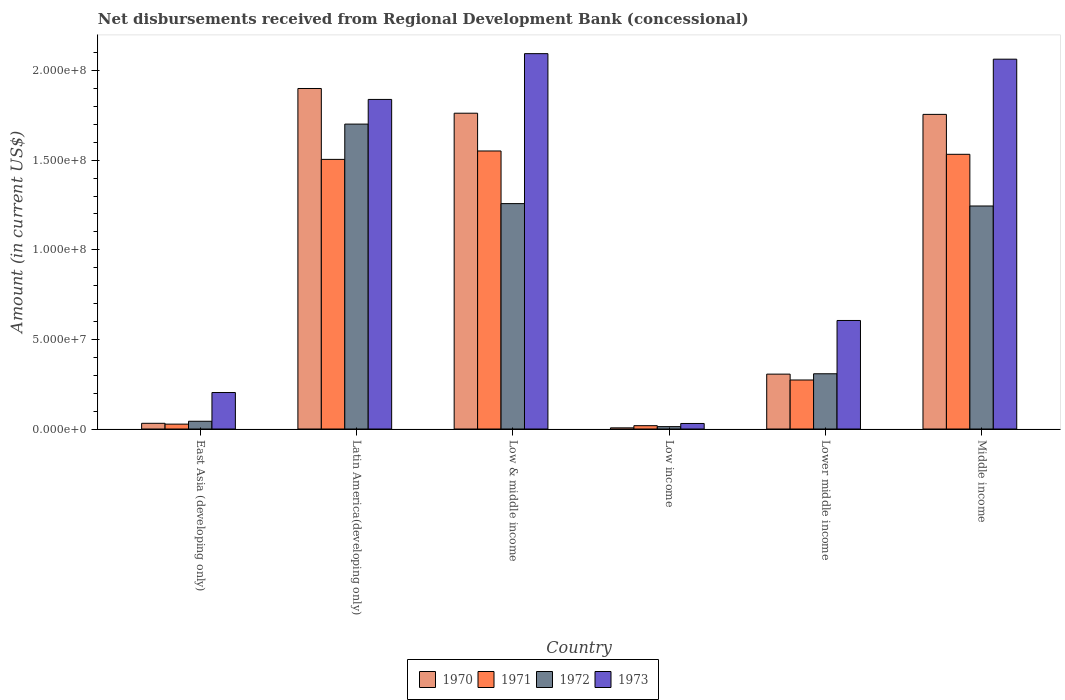How many groups of bars are there?
Your response must be concise. 6. Are the number of bars on each tick of the X-axis equal?
Ensure brevity in your answer.  Yes. How many bars are there on the 1st tick from the left?
Provide a succinct answer. 4. In how many cases, is the number of bars for a given country not equal to the number of legend labels?
Provide a succinct answer. 0. What is the amount of disbursements received from Regional Development Bank in 1973 in Low income?
Offer a terse response. 3.09e+06. Across all countries, what is the maximum amount of disbursements received from Regional Development Bank in 1971?
Ensure brevity in your answer.  1.55e+08. Across all countries, what is the minimum amount of disbursements received from Regional Development Bank in 1971?
Ensure brevity in your answer.  1.86e+06. In which country was the amount of disbursements received from Regional Development Bank in 1970 maximum?
Provide a short and direct response. Latin America(developing only). In which country was the amount of disbursements received from Regional Development Bank in 1970 minimum?
Ensure brevity in your answer.  Low income. What is the total amount of disbursements received from Regional Development Bank in 1970 in the graph?
Offer a very short reply. 5.76e+08. What is the difference between the amount of disbursements received from Regional Development Bank in 1973 in East Asia (developing only) and that in Lower middle income?
Offer a terse response. -4.02e+07. What is the difference between the amount of disbursements received from Regional Development Bank in 1973 in Middle income and the amount of disbursements received from Regional Development Bank in 1970 in Low & middle income?
Provide a short and direct response. 3.01e+07. What is the average amount of disbursements received from Regional Development Bank in 1973 per country?
Keep it short and to the point. 1.14e+08. What is the difference between the amount of disbursements received from Regional Development Bank of/in 1973 and amount of disbursements received from Regional Development Bank of/in 1972 in Middle income?
Offer a very short reply. 8.19e+07. What is the ratio of the amount of disbursements received from Regional Development Bank in 1972 in Latin America(developing only) to that in Low income?
Provide a succinct answer. 127.63. What is the difference between the highest and the second highest amount of disbursements received from Regional Development Bank in 1972?
Make the answer very short. 4.44e+07. What is the difference between the highest and the lowest amount of disbursements received from Regional Development Bank in 1973?
Your response must be concise. 2.06e+08. What does the 3rd bar from the left in Low income represents?
Your answer should be compact. 1972. Are all the bars in the graph horizontal?
Your answer should be compact. No. What is the difference between two consecutive major ticks on the Y-axis?
Your answer should be compact. 5.00e+07. Are the values on the major ticks of Y-axis written in scientific E-notation?
Your answer should be very brief. Yes. Does the graph contain grids?
Make the answer very short. No. Where does the legend appear in the graph?
Give a very brief answer. Bottom center. How many legend labels are there?
Provide a short and direct response. 4. What is the title of the graph?
Provide a succinct answer. Net disbursements received from Regional Development Bank (concessional). Does "2002" appear as one of the legend labels in the graph?
Make the answer very short. No. What is the Amount (in current US$) in 1970 in East Asia (developing only)?
Ensure brevity in your answer.  3.19e+06. What is the Amount (in current US$) of 1971 in East Asia (developing only)?
Make the answer very short. 2.73e+06. What is the Amount (in current US$) in 1972 in East Asia (developing only)?
Your response must be concise. 4.33e+06. What is the Amount (in current US$) in 1973 in East Asia (developing only)?
Offer a terse response. 2.04e+07. What is the Amount (in current US$) in 1970 in Latin America(developing only)?
Your answer should be very brief. 1.90e+08. What is the Amount (in current US$) of 1971 in Latin America(developing only)?
Your answer should be very brief. 1.50e+08. What is the Amount (in current US$) of 1972 in Latin America(developing only)?
Offer a terse response. 1.70e+08. What is the Amount (in current US$) of 1973 in Latin America(developing only)?
Provide a succinct answer. 1.84e+08. What is the Amount (in current US$) in 1970 in Low & middle income?
Make the answer very short. 1.76e+08. What is the Amount (in current US$) of 1971 in Low & middle income?
Make the answer very short. 1.55e+08. What is the Amount (in current US$) of 1972 in Low & middle income?
Keep it short and to the point. 1.26e+08. What is the Amount (in current US$) in 1973 in Low & middle income?
Provide a short and direct response. 2.09e+08. What is the Amount (in current US$) in 1970 in Low income?
Make the answer very short. 6.47e+05. What is the Amount (in current US$) of 1971 in Low income?
Provide a short and direct response. 1.86e+06. What is the Amount (in current US$) of 1972 in Low income?
Give a very brief answer. 1.33e+06. What is the Amount (in current US$) in 1973 in Low income?
Provide a short and direct response. 3.09e+06. What is the Amount (in current US$) in 1970 in Lower middle income?
Provide a succinct answer. 3.06e+07. What is the Amount (in current US$) in 1971 in Lower middle income?
Provide a short and direct response. 2.74e+07. What is the Amount (in current US$) of 1972 in Lower middle income?
Provide a short and direct response. 3.08e+07. What is the Amount (in current US$) of 1973 in Lower middle income?
Provide a short and direct response. 6.06e+07. What is the Amount (in current US$) of 1970 in Middle income?
Make the answer very short. 1.76e+08. What is the Amount (in current US$) of 1971 in Middle income?
Offer a terse response. 1.53e+08. What is the Amount (in current US$) of 1972 in Middle income?
Your response must be concise. 1.24e+08. What is the Amount (in current US$) of 1973 in Middle income?
Give a very brief answer. 2.06e+08. Across all countries, what is the maximum Amount (in current US$) of 1970?
Make the answer very short. 1.90e+08. Across all countries, what is the maximum Amount (in current US$) in 1971?
Your response must be concise. 1.55e+08. Across all countries, what is the maximum Amount (in current US$) in 1972?
Offer a very short reply. 1.70e+08. Across all countries, what is the maximum Amount (in current US$) of 1973?
Make the answer very short. 2.09e+08. Across all countries, what is the minimum Amount (in current US$) in 1970?
Ensure brevity in your answer.  6.47e+05. Across all countries, what is the minimum Amount (in current US$) in 1971?
Your response must be concise. 1.86e+06. Across all countries, what is the minimum Amount (in current US$) in 1972?
Give a very brief answer. 1.33e+06. Across all countries, what is the minimum Amount (in current US$) in 1973?
Provide a short and direct response. 3.09e+06. What is the total Amount (in current US$) of 1970 in the graph?
Make the answer very short. 5.76e+08. What is the total Amount (in current US$) in 1971 in the graph?
Your answer should be very brief. 4.91e+08. What is the total Amount (in current US$) in 1972 in the graph?
Ensure brevity in your answer.  4.57e+08. What is the total Amount (in current US$) in 1973 in the graph?
Offer a very short reply. 6.84e+08. What is the difference between the Amount (in current US$) in 1970 in East Asia (developing only) and that in Latin America(developing only)?
Offer a terse response. -1.87e+08. What is the difference between the Amount (in current US$) in 1971 in East Asia (developing only) and that in Latin America(developing only)?
Provide a succinct answer. -1.48e+08. What is the difference between the Amount (in current US$) in 1972 in East Asia (developing only) and that in Latin America(developing only)?
Keep it short and to the point. -1.66e+08. What is the difference between the Amount (in current US$) in 1973 in East Asia (developing only) and that in Latin America(developing only)?
Offer a terse response. -1.64e+08. What is the difference between the Amount (in current US$) in 1970 in East Asia (developing only) and that in Low & middle income?
Your answer should be very brief. -1.73e+08. What is the difference between the Amount (in current US$) in 1971 in East Asia (developing only) and that in Low & middle income?
Provide a short and direct response. -1.52e+08. What is the difference between the Amount (in current US$) of 1972 in East Asia (developing only) and that in Low & middle income?
Give a very brief answer. -1.21e+08. What is the difference between the Amount (in current US$) in 1973 in East Asia (developing only) and that in Low & middle income?
Give a very brief answer. -1.89e+08. What is the difference between the Amount (in current US$) in 1970 in East Asia (developing only) and that in Low income?
Ensure brevity in your answer.  2.54e+06. What is the difference between the Amount (in current US$) in 1971 in East Asia (developing only) and that in Low income?
Your answer should be very brief. 8.69e+05. What is the difference between the Amount (in current US$) of 1972 in East Asia (developing only) and that in Low income?
Your response must be concise. 2.99e+06. What is the difference between the Amount (in current US$) in 1973 in East Asia (developing only) and that in Low income?
Provide a succinct answer. 1.73e+07. What is the difference between the Amount (in current US$) of 1970 in East Asia (developing only) and that in Lower middle income?
Your response must be concise. -2.74e+07. What is the difference between the Amount (in current US$) of 1971 in East Asia (developing only) and that in Lower middle income?
Your answer should be compact. -2.46e+07. What is the difference between the Amount (in current US$) in 1972 in East Asia (developing only) and that in Lower middle income?
Your answer should be very brief. -2.65e+07. What is the difference between the Amount (in current US$) in 1973 in East Asia (developing only) and that in Lower middle income?
Make the answer very short. -4.02e+07. What is the difference between the Amount (in current US$) of 1970 in East Asia (developing only) and that in Middle income?
Make the answer very short. -1.72e+08. What is the difference between the Amount (in current US$) of 1971 in East Asia (developing only) and that in Middle income?
Provide a short and direct response. -1.51e+08. What is the difference between the Amount (in current US$) of 1972 in East Asia (developing only) and that in Middle income?
Offer a very short reply. -1.20e+08. What is the difference between the Amount (in current US$) of 1973 in East Asia (developing only) and that in Middle income?
Make the answer very short. -1.86e+08. What is the difference between the Amount (in current US$) of 1970 in Latin America(developing only) and that in Low & middle income?
Give a very brief answer. 1.38e+07. What is the difference between the Amount (in current US$) of 1971 in Latin America(developing only) and that in Low & middle income?
Your response must be concise. -4.69e+06. What is the difference between the Amount (in current US$) in 1972 in Latin America(developing only) and that in Low & middle income?
Your response must be concise. 4.44e+07. What is the difference between the Amount (in current US$) of 1973 in Latin America(developing only) and that in Low & middle income?
Keep it short and to the point. -2.55e+07. What is the difference between the Amount (in current US$) of 1970 in Latin America(developing only) and that in Low income?
Offer a very short reply. 1.89e+08. What is the difference between the Amount (in current US$) of 1971 in Latin America(developing only) and that in Low income?
Make the answer very short. 1.49e+08. What is the difference between the Amount (in current US$) in 1972 in Latin America(developing only) and that in Low income?
Give a very brief answer. 1.69e+08. What is the difference between the Amount (in current US$) in 1973 in Latin America(developing only) and that in Low income?
Ensure brevity in your answer.  1.81e+08. What is the difference between the Amount (in current US$) of 1970 in Latin America(developing only) and that in Lower middle income?
Make the answer very short. 1.59e+08. What is the difference between the Amount (in current US$) in 1971 in Latin America(developing only) and that in Lower middle income?
Provide a succinct answer. 1.23e+08. What is the difference between the Amount (in current US$) in 1972 in Latin America(developing only) and that in Lower middle income?
Your response must be concise. 1.39e+08. What is the difference between the Amount (in current US$) in 1973 in Latin America(developing only) and that in Lower middle income?
Ensure brevity in your answer.  1.23e+08. What is the difference between the Amount (in current US$) of 1970 in Latin America(developing only) and that in Middle income?
Your answer should be very brief. 1.44e+07. What is the difference between the Amount (in current US$) in 1971 in Latin America(developing only) and that in Middle income?
Provide a short and direct response. -2.84e+06. What is the difference between the Amount (in current US$) in 1972 in Latin America(developing only) and that in Middle income?
Keep it short and to the point. 4.57e+07. What is the difference between the Amount (in current US$) in 1973 in Latin America(developing only) and that in Middle income?
Provide a succinct answer. -2.25e+07. What is the difference between the Amount (in current US$) of 1970 in Low & middle income and that in Low income?
Make the answer very short. 1.76e+08. What is the difference between the Amount (in current US$) in 1971 in Low & middle income and that in Low income?
Give a very brief answer. 1.53e+08. What is the difference between the Amount (in current US$) of 1972 in Low & middle income and that in Low income?
Your answer should be very brief. 1.24e+08. What is the difference between the Amount (in current US$) in 1973 in Low & middle income and that in Low income?
Provide a succinct answer. 2.06e+08. What is the difference between the Amount (in current US$) in 1970 in Low & middle income and that in Lower middle income?
Provide a short and direct response. 1.46e+08. What is the difference between the Amount (in current US$) of 1971 in Low & middle income and that in Lower middle income?
Make the answer very short. 1.28e+08. What is the difference between the Amount (in current US$) of 1972 in Low & middle income and that in Lower middle income?
Keep it short and to the point. 9.49e+07. What is the difference between the Amount (in current US$) of 1973 in Low & middle income and that in Lower middle income?
Ensure brevity in your answer.  1.49e+08. What is the difference between the Amount (in current US$) of 1970 in Low & middle income and that in Middle income?
Offer a very short reply. 6.47e+05. What is the difference between the Amount (in current US$) in 1971 in Low & middle income and that in Middle income?
Your response must be concise. 1.86e+06. What is the difference between the Amount (in current US$) of 1972 in Low & middle income and that in Middle income?
Give a very brief answer. 1.33e+06. What is the difference between the Amount (in current US$) of 1973 in Low & middle income and that in Middle income?
Offer a terse response. 3.09e+06. What is the difference between the Amount (in current US$) of 1970 in Low income and that in Lower middle income?
Offer a terse response. -3.00e+07. What is the difference between the Amount (in current US$) in 1971 in Low income and that in Lower middle income?
Provide a succinct answer. -2.55e+07. What is the difference between the Amount (in current US$) in 1972 in Low income and that in Lower middle income?
Ensure brevity in your answer.  -2.95e+07. What is the difference between the Amount (in current US$) in 1973 in Low income and that in Lower middle income?
Provide a succinct answer. -5.75e+07. What is the difference between the Amount (in current US$) of 1970 in Low income and that in Middle income?
Provide a short and direct response. -1.75e+08. What is the difference between the Amount (in current US$) in 1971 in Low income and that in Middle income?
Your answer should be very brief. -1.51e+08. What is the difference between the Amount (in current US$) of 1972 in Low income and that in Middle income?
Provide a succinct answer. -1.23e+08. What is the difference between the Amount (in current US$) in 1973 in Low income and that in Middle income?
Offer a very short reply. -2.03e+08. What is the difference between the Amount (in current US$) in 1970 in Lower middle income and that in Middle income?
Your answer should be very brief. -1.45e+08. What is the difference between the Amount (in current US$) in 1971 in Lower middle income and that in Middle income?
Offer a very short reply. -1.26e+08. What is the difference between the Amount (in current US$) of 1972 in Lower middle income and that in Middle income?
Give a very brief answer. -9.36e+07. What is the difference between the Amount (in current US$) in 1973 in Lower middle income and that in Middle income?
Give a very brief answer. -1.46e+08. What is the difference between the Amount (in current US$) in 1970 in East Asia (developing only) and the Amount (in current US$) in 1971 in Latin America(developing only)?
Ensure brevity in your answer.  -1.47e+08. What is the difference between the Amount (in current US$) in 1970 in East Asia (developing only) and the Amount (in current US$) in 1972 in Latin America(developing only)?
Make the answer very short. -1.67e+08. What is the difference between the Amount (in current US$) in 1970 in East Asia (developing only) and the Amount (in current US$) in 1973 in Latin America(developing only)?
Offer a very short reply. -1.81e+08. What is the difference between the Amount (in current US$) of 1971 in East Asia (developing only) and the Amount (in current US$) of 1972 in Latin America(developing only)?
Your answer should be compact. -1.67e+08. What is the difference between the Amount (in current US$) of 1971 in East Asia (developing only) and the Amount (in current US$) of 1973 in Latin America(developing only)?
Offer a terse response. -1.81e+08. What is the difference between the Amount (in current US$) in 1972 in East Asia (developing only) and the Amount (in current US$) in 1973 in Latin America(developing only)?
Keep it short and to the point. -1.80e+08. What is the difference between the Amount (in current US$) in 1970 in East Asia (developing only) and the Amount (in current US$) in 1971 in Low & middle income?
Provide a succinct answer. -1.52e+08. What is the difference between the Amount (in current US$) in 1970 in East Asia (developing only) and the Amount (in current US$) in 1972 in Low & middle income?
Your answer should be very brief. -1.23e+08. What is the difference between the Amount (in current US$) in 1970 in East Asia (developing only) and the Amount (in current US$) in 1973 in Low & middle income?
Ensure brevity in your answer.  -2.06e+08. What is the difference between the Amount (in current US$) of 1971 in East Asia (developing only) and the Amount (in current US$) of 1972 in Low & middle income?
Offer a terse response. -1.23e+08. What is the difference between the Amount (in current US$) of 1971 in East Asia (developing only) and the Amount (in current US$) of 1973 in Low & middle income?
Ensure brevity in your answer.  -2.07e+08. What is the difference between the Amount (in current US$) of 1972 in East Asia (developing only) and the Amount (in current US$) of 1973 in Low & middle income?
Offer a very short reply. -2.05e+08. What is the difference between the Amount (in current US$) in 1970 in East Asia (developing only) and the Amount (in current US$) in 1971 in Low income?
Your answer should be compact. 1.33e+06. What is the difference between the Amount (in current US$) in 1970 in East Asia (developing only) and the Amount (in current US$) in 1972 in Low income?
Give a very brief answer. 1.86e+06. What is the difference between the Amount (in current US$) in 1970 in East Asia (developing only) and the Amount (in current US$) in 1973 in Low income?
Ensure brevity in your answer.  9.80e+04. What is the difference between the Amount (in current US$) in 1971 in East Asia (developing only) and the Amount (in current US$) in 1972 in Low income?
Your answer should be very brief. 1.40e+06. What is the difference between the Amount (in current US$) of 1971 in East Asia (developing only) and the Amount (in current US$) of 1973 in Low income?
Keep it short and to the point. -3.63e+05. What is the difference between the Amount (in current US$) in 1972 in East Asia (developing only) and the Amount (in current US$) in 1973 in Low income?
Your answer should be very brief. 1.24e+06. What is the difference between the Amount (in current US$) of 1970 in East Asia (developing only) and the Amount (in current US$) of 1971 in Lower middle income?
Make the answer very short. -2.42e+07. What is the difference between the Amount (in current US$) of 1970 in East Asia (developing only) and the Amount (in current US$) of 1972 in Lower middle income?
Make the answer very short. -2.76e+07. What is the difference between the Amount (in current US$) in 1970 in East Asia (developing only) and the Amount (in current US$) in 1973 in Lower middle income?
Your answer should be very brief. -5.74e+07. What is the difference between the Amount (in current US$) in 1971 in East Asia (developing only) and the Amount (in current US$) in 1972 in Lower middle income?
Ensure brevity in your answer.  -2.81e+07. What is the difference between the Amount (in current US$) of 1971 in East Asia (developing only) and the Amount (in current US$) of 1973 in Lower middle income?
Offer a terse response. -5.78e+07. What is the difference between the Amount (in current US$) of 1972 in East Asia (developing only) and the Amount (in current US$) of 1973 in Lower middle income?
Offer a very short reply. -5.62e+07. What is the difference between the Amount (in current US$) in 1970 in East Asia (developing only) and the Amount (in current US$) in 1971 in Middle income?
Make the answer very short. -1.50e+08. What is the difference between the Amount (in current US$) of 1970 in East Asia (developing only) and the Amount (in current US$) of 1972 in Middle income?
Offer a terse response. -1.21e+08. What is the difference between the Amount (in current US$) in 1970 in East Asia (developing only) and the Amount (in current US$) in 1973 in Middle income?
Make the answer very short. -2.03e+08. What is the difference between the Amount (in current US$) in 1971 in East Asia (developing only) and the Amount (in current US$) in 1972 in Middle income?
Your response must be concise. -1.22e+08. What is the difference between the Amount (in current US$) in 1971 in East Asia (developing only) and the Amount (in current US$) in 1973 in Middle income?
Ensure brevity in your answer.  -2.04e+08. What is the difference between the Amount (in current US$) in 1972 in East Asia (developing only) and the Amount (in current US$) in 1973 in Middle income?
Give a very brief answer. -2.02e+08. What is the difference between the Amount (in current US$) of 1970 in Latin America(developing only) and the Amount (in current US$) of 1971 in Low & middle income?
Offer a terse response. 3.49e+07. What is the difference between the Amount (in current US$) of 1970 in Latin America(developing only) and the Amount (in current US$) of 1972 in Low & middle income?
Give a very brief answer. 6.42e+07. What is the difference between the Amount (in current US$) of 1970 in Latin America(developing only) and the Amount (in current US$) of 1973 in Low & middle income?
Your answer should be compact. -1.94e+07. What is the difference between the Amount (in current US$) in 1971 in Latin America(developing only) and the Amount (in current US$) in 1972 in Low & middle income?
Ensure brevity in your answer.  2.47e+07. What is the difference between the Amount (in current US$) of 1971 in Latin America(developing only) and the Amount (in current US$) of 1973 in Low & middle income?
Your response must be concise. -5.90e+07. What is the difference between the Amount (in current US$) of 1972 in Latin America(developing only) and the Amount (in current US$) of 1973 in Low & middle income?
Your answer should be compact. -3.93e+07. What is the difference between the Amount (in current US$) in 1970 in Latin America(developing only) and the Amount (in current US$) in 1971 in Low income?
Give a very brief answer. 1.88e+08. What is the difference between the Amount (in current US$) in 1970 in Latin America(developing only) and the Amount (in current US$) in 1972 in Low income?
Offer a very short reply. 1.89e+08. What is the difference between the Amount (in current US$) in 1970 in Latin America(developing only) and the Amount (in current US$) in 1973 in Low income?
Give a very brief answer. 1.87e+08. What is the difference between the Amount (in current US$) in 1971 in Latin America(developing only) and the Amount (in current US$) in 1972 in Low income?
Your answer should be very brief. 1.49e+08. What is the difference between the Amount (in current US$) in 1971 in Latin America(developing only) and the Amount (in current US$) in 1973 in Low income?
Ensure brevity in your answer.  1.47e+08. What is the difference between the Amount (in current US$) of 1972 in Latin America(developing only) and the Amount (in current US$) of 1973 in Low income?
Keep it short and to the point. 1.67e+08. What is the difference between the Amount (in current US$) of 1970 in Latin America(developing only) and the Amount (in current US$) of 1971 in Lower middle income?
Ensure brevity in your answer.  1.63e+08. What is the difference between the Amount (in current US$) of 1970 in Latin America(developing only) and the Amount (in current US$) of 1972 in Lower middle income?
Your response must be concise. 1.59e+08. What is the difference between the Amount (in current US$) of 1970 in Latin America(developing only) and the Amount (in current US$) of 1973 in Lower middle income?
Give a very brief answer. 1.29e+08. What is the difference between the Amount (in current US$) in 1971 in Latin America(developing only) and the Amount (in current US$) in 1972 in Lower middle income?
Your answer should be very brief. 1.20e+08. What is the difference between the Amount (in current US$) in 1971 in Latin America(developing only) and the Amount (in current US$) in 1973 in Lower middle income?
Offer a very short reply. 8.99e+07. What is the difference between the Amount (in current US$) of 1972 in Latin America(developing only) and the Amount (in current US$) of 1973 in Lower middle income?
Keep it short and to the point. 1.10e+08. What is the difference between the Amount (in current US$) of 1970 in Latin America(developing only) and the Amount (in current US$) of 1971 in Middle income?
Your answer should be very brief. 3.67e+07. What is the difference between the Amount (in current US$) of 1970 in Latin America(developing only) and the Amount (in current US$) of 1972 in Middle income?
Keep it short and to the point. 6.56e+07. What is the difference between the Amount (in current US$) in 1970 in Latin America(developing only) and the Amount (in current US$) in 1973 in Middle income?
Your answer should be very brief. -1.64e+07. What is the difference between the Amount (in current US$) of 1971 in Latin America(developing only) and the Amount (in current US$) of 1972 in Middle income?
Keep it short and to the point. 2.60e+07. What is the difference between the Amount (in current US$) in 1971 in Latin America(developing only) and the Amount (in current US$) in 1973 in Middle income?
Provide a succinct answer. -5.59e+07. What is the difference between the Amount (in current US$) in 1972 in Latin America(developing only) and the Amount (in current US$) in 1973 in Middle income?
Offer a terse response. -3.62e+07. What is the difference between the Amount (in current US$) in 1970 in Low & middle income and the Amount (in current US$) in 1971 in Low income?
Offer a very short reply. 1.74e+08. What is the difference between the Amount (in current US$) of 1970 in Low & middle income and the Amount (in current US$) of 1972 in Low income?
Your response must be concise. 1.75e+08. What is the difference between the Amount (in current US$) of 1970 in Low & middle income and the Amount (in current US$) of 1973 in Low income?
Keep it short and to the point. 1.73e+08. What is the difference between the Amount (in current US$) of 1971 in Low & middle income and the Amount (in current US$) of 1972 in Low income?
Give a very brief answer. 1.54e+08. What is the difference between the Amount (in current US$) of 1971 in Low & middle income and the Amount (in current US$) of 1973 in Low income?
Your answer should be very brief. 1.52e+08. What is the difference between the Amount (in current US$) in 1972 in Low & middle income and the Amount (in current US$) in 1973 in Low income?
Keep it short and to the point. 1.23e+08. What is the difference between the Amount (in current US$) of 1970 in Low & middle income and the Amount (in current US$) of 1971 in Lower middle income?
Make the answer very short. 1.49e+08. What is the difference between the Amount (in current US$) of 1970 in Low & middle income and the Amount (in current US$) of 1972 in Lower middle income?
Your answer should be compact. 1.45e+08. What is the difference between the Amount (in current US$) of 1970 in Low & middle income and the Amount (in current US$) of 1973 in Lower middle income?
Your response must be concise. 1.16e+08. What is the difference between the Amount (in current US$) in 1971 in Low & middle income and the Amount (in current US$) in 1972 in Lower middle income?
Offer a terse response. 1.24e+08. What is the difference between the Amount (in current US$) of 1971 in Low & middle income and the Amount (in current US$) of 1973 in Lower middle income?
Your answer should be very brief. 9.46e+07. What is the difference between the Amount (in current US$) in 1972 in Low & middle income and the Amount (in current US$) in 1973 in Lower middle income?
Provide a short and direct response. 6.52e+07. What is the difference between the Amount (in current US$) in 1970 in Low & middle income and the Amount (in current US$) in 1971 in Middle income?
Your response must be concise. 2.29e+07. What is the difference between the Amount (in current US$) of 1970 in Low & middle income and the Amount (in current US$) of 1972 in Middle income?
Provide a short and direct response. 5.18e+07. What is the difference between the Amount (in current US$) of 1970 in Low & middle income and the Amount (in current US$) of 1973 in Middle income?
Give a very brief answer. -3.01e+07. What is the difference between the Amount (in current US$) in 1971 in Low & middle income and the Amount (in current US$) in 1972 in Middle income?
Your answer should be very brief. 3.07e+07. What is the difference between the Amount (in current US$) of 1971 in Low & middle income and the Amount (in current US$) of 1973 in Middle income?
Ensure brevity in your answer.  -5.12e+07. What is the difference between the Amount (in current US$) in 1972 in Low & middle income and the Amount (in current US$) in 1973 in Middle income?
Provide a succinct answer. -8.06e+07. What is the difference between the Amount (in current US$) in 1970 in Low income and the Amount (in current US$) in 1971 in Lower middle income?
Keep it short and to the point. -2.67e+07. What is the difference between the Amount (in current US$) of 1970 in Low income and the Amount (in current US$) of 1972 in Lower middle income?
Offer a very short reply. -3.02e+07. What is the difference between the Amount (in current US$) of 1970 in Low income and the Amount (in current US$) of 1973 in Lower middle income?
Ensure brevity in your answer.  -5.99e+07. What is the difference between the Amount (in current US$) in 1971 in Low income and the Amount (in current US$) in 1972 in Lower middle income?
Keep it short and to the point. -2.90e+07. What is the difference between the Amount (in current US$) in 1971 in Low income and the Amount (in current US$) in 1973 in Lower middle income?
Offer a terse response. -5.87e+07. What is the difference between the Amount (in current US$) of 1972 in Low income and the Amount (in current US$) of 1973 in Lower middle income?
Offer a terse response. -5.92e+07. What is the difference between the Amount (in current US$) in 1970 in Low income and the Amount (in current US$) in 1971 in Middle income?
Offer a terse response. -1.53e+08. What is the difference between the Amount (in current US$) of 1970 in Low income and the Amount (in current US$) of 1972 in Middle income?
Give a very brief answer. -1.24e+08. What is the difference between the Amount (in current US$) of 1970 in Low income and the Amount (in current US$) of 1973 in Middle income?
Keep it short and to the point. -2.06e+08. What is the difference between the Amount (in current US$) of 1971 in Low income and the Amount (in current US$) of 1972 in Middle income?
Give a very brief answer. -1.23e+08. What is the difference between the Amount (in current US$) in 1971 in Low income and the Amount (in current US$) in 1973 in Middle income?
Provide a succinct answer. -2.04e+08. What is the difference between the Amount (in current US$) of 1972 in Low income and the Amount (in current US$) of 1973 in Middle income?
Ensure brevity in your answer.  -2.05e+08. What is the difference between the Amount (in current US$) in 1970 in Lower middle income and the Amount (in current US$) in 1971 in Middle income?
Your answer should be very brief. -1.23e+08. What is the difference between the Amount (in current US$) in 1970 in Lower middle income and the Amount (in current US$) in 1972 in Middle income?
Provide a short and direct response. -9.38e+07. What is the difference between the Amount (in current US$) of 1970 in Lower middle income and the Amount (in current US$) of 1973 in Middle income?
Make the answer very short. -1.76e+08. What is the difference between the Amount (in current US$) of 1971 in Lower middle income and the Amount (in current US$) of 1972 in Middle income?
Offer a terse response. -9.71e+07. What is the difference between the Amount (in current US$) in 1971 in Lower middle income and the Amount (in current US$) in 1973 in Middle income?
Provide a succinct answer. -1.79e+08. What is the difference between the Amount (in current US$) of 1972 in Lower middle income and the Amount (in current US$) of 1973 in Middle income?
Offer a very short reply. -1.76e+08. What is the average Amount (in current US$) in 1970 per country?
Offer a terse response. 9.60e+07. What is the average Amount (in current US$) in 1971 per country?
Your response must be concise. 8.18e+07. What is the average Amount (in current US$) in 1972 per country?
Keep it short and to the point. 7.61e+07. What is the average Amount (in current US$) in 1973 per country?
Provide a short and direct response. 1.14e+08. What is the difference between the Amount (in current US$) of 1970 and Amount (in current US$) of 1971 in East Asia (developing only)?
Provide a succinct answer. 4.61e+05. What is the difference between the Amount (in current US$) of 1970 and Amount (in current US$) of 1972 in East Asia (developing only)?
Your response must be concise. -1.14e+06. What is the difference between the Amount (in current US$) of 1970 and Amount (in current US$) of 1973 in East Asia (developing only)?
Your answer should be very brief. -1.72e+07. What is the difference between the Amount (in current US$) in 1971 and Amount (in current US$) in 1972 in East Asia (developing only)?
Ensure brevity in your answer.  -1.60e+06. What is the difference between the Amount (in current US$) in 1971 and Amount (in current US$) in 1973 in East Asia (developing only)?
Offer a terse response. -1.76e+07. What is the difference between the Amount (in current US$) of 1972 and Amount (in current US$) of 1973 in East Asia (developing only)?
Keep it short and to the point. -1.60e+07. What is the difference between the Amount (in current US$) in 1970 and Amount (in current US$) in 1971 in Latin America(developing only)?
Your answer should be very brief. 3.96e+07. What is the difference between the Amount (in current US$) in 1970 and Amount (in current US$) in 1972 in Latin America(developing only)?
Offer a terse response. 1.99e+07. What is the difference between the Amount (in current US$) in 1970 and Amount (in current US$) in 1973 in Latin America(developing only)?
Ensure brevity in your answer.  6.10e+06. What is the difference between the Amount (in current US$) in 1971 and Amount (in current US$) in 1972 in Latin America(developing only)?
Provide a short and direct response. -1.97e+07. What is the difference between the Amount (in current US$) in 1971 and Amount (in current US$) in 1973 in Latin America(developing only)?
Ensure brevity in your answer.  -3.35e+07. What is the difference between the Amount (in current US$) in 1972 and Amount (in current US$) in 1973 in Latin America(developing only)?
Your response must be concise. -1.38e+07. What is the difference between the Amount (in current US$) in 1970 and Amount (in current US$) in 1971 in Low & middle income?
Ensure brevity in your answer.  2.11e+07. What is the difference between the Amount (in current US$) of 1970 and Amount (in current US$) of 1972 in Low & middle income?
Offer a terse response. 5.04e+07. What is the difference between the Amount (in current US$) of 1970 and Amount (in current US$) of 1973 in Low & middle income?
Your answer should be very brief. -3.32e+07. What is the difference between the Amount (in current US$) in 1971 and Amount (in current US$) in 1972 in Low & middle income?
Your response must be concise. 2.94e+07. What is the difference between the Amount (in current US$) in 1971 and Amount (in current US$) in 1973 in Low & middle income?
Your response must be concise. -5.43e+07. What is the difference between the Amount (in current US$) of 1972 and Amount (in current US$) of 1973 in Low & middle income?
Give a very brief answer. -8.37e+07. What is the difference between the Amount (in current US$) in 1970 and Amount (in current US$) in 1971 in Low income?
Offer a terse response. -1.21e+06. What is the difference between the Amount (in current US$) of 1970 and Amount (in current US$) of 1972 in Low income?
Ensure brevity in your answer.  -6.86e+05. What is the difference between the Amount (in current US$) in 1970 and Amount (in current US$) in 1973 in Low income?
Provide a succinct answer. -2.44e+06. What is the difference between the Amount (in current US$) in 1971 and Amount (in current US$) in 1972 in Low income?
Provide a succinct answer. 5.26e+05. What is the difference between the Amount (in current US$) in 1971 and Amount (in current US$) in 1973 in Low income?
Your answer should be very brief. -1.23e+06. What is the difference between the Amount (in current US$) of 1972 and Amount (in current US$) of 1973 in Low income?
Ensure brevity in your answer.  -1.76e+06. What is the difference between the Amount (in current US$) in 1970 and Amount (in current US$) in 1971 in Lower middle income?
Your answer should be very brief. 3.27e+06. What is the difference between the Amount (in current US$) in 1970 and Amount (in current US$) in 1972 in Lower middle income?
Your answer should be compact. -2.02e+05. What is the difference between the Amount (in current US$) of 1970 and Amount (in current US$) of 1973 in Lower middle income?
Offer a very short reply. -2.99e+07. What is the difference between the Amount (in current US$) of 1971 and Amount (in current US$) of 1972 in Lower middle income?
Give a very brief answer. -3.47e+06. What is the difference between the Amount (in current US$) of 1971 and Amount (in current US$) of 1973 in Lower middle income?
Offer a terse response. -3.32e+07. What is the difference between the Amount (in current US$) in 1972 and Amount (in current US$) in 1973 in Lower middle income?
Keep it short and to the point. -2.97e+07. What is the difference between the Amount (in current US$) in 1970 and Amount (in current US$) in 1971 in Middle income?
Ensure brevity in your answer.  2.23e+07. What is the difference between the Amount (in current US$) of 1970 and Amount (in current US$) of 1972 in Middle income?
Give a very brief answer. 5.11e+07. What is the difference between the Amount (in current US$) in 1970 and Amount (in current US$) in 1973 in Middle income?
Your answer should be compact. -3.08e+07. What is the difference between the Amount (in current US$) of 1971 and Amount (in current US$) of 1972 in Middle income?
Keep it short and to the point. 2.88e+07. What is the difference between the Amount (in current US$) of 1971 and Amount (in current US$) of 1973 in Middle income?
Your response must be concise. -5.31e+07. What is the difference between the Amount (in current US$) of 1972 and Amount (in current US$) of 1973 in Middle income?
Give a very brief answer. -8.19e+07. What is the ratio of the Amount (in current US$) of 1970 in East Asia (developing only) to that in Latin America(developing only)?
Your answer should be very brief. 0.02. What is the ratio of the Amount (in current US$) in 1971 in East Asia (developing only) to that in Latin America(developing only)?
Offer a very short reply. 0.02. What is the ratio of the Amount (in current US$) of 1972 in East Asia (developing only) to that in Latin America(developing only)?
Provide a succinct answer. 0.03. What is the ratio of the Amount (in current US$) in 1973 in East Asia (developing only) to that in Latin America(developing only)?
Your answer should be compact. 0.11. What is the ratio of the Amount (in current US$) in 1970 in East Asia (developing only) to that in Low & middle income?
Make the answer very short. 0.02. What is the ratio of the Amount (in current US$) of 1971 in East Asia (developing only) to that in Low & middle income?
Your answer should be very brief. 0.02. What is the ratio of the Amount (in current US$) of 1972 in East Asia (developing only) to that in Low & middle income?
Your answer should be compact. 0.03. What is the ratio of the Amount (in current US$) in 1973 in East Asia (developing only) to that in Low & middle income?
Your answer should be very brief. 0.1. What is the ratio of the Amount (in current US$) in 1970 in East Asia (developing only) to that in Low income?
Give a very brief answer. 4.93. What is the ratio of the Amount (in current US$) of 1971 in East Asia (developing only) to that in Low income?
Provide a short and direct response. 1.47. What is the ratio of the Amount (in current US$) of 1972 in East Asia (developing only) to that in Low income?
Offer a very short reply. 3.25. What is the ratio of the Amount (in current US$) of 1973 in East Asia (developing only) to that in Low income?
Make the answer very short. 6.59. What is the ratio of the Amount (in current US$) in 1970 in East Asia (developing only) to that in Lower middle income?
Offer a terse response. 0.1. What is the ratio of the Amount (in current US$) of 1971 in East Asia (developing only) to that in Lower middle income?
Your answer should be compact. 0.1. What is the ratio of the Amount (in current US$) in 1972 in East Asia (developing only) to that in Lower middle income?
Your answer should be very brief. 0.14. What is the ratio of the Amount (in current US$) of 1973 in East Asia (developing only) to that in Lower middle income?
Your answer should be compact. 0.34. What is the ratio of the Amount (in current US$) of 1970 in East Asia (developing only) to that in Middle income?
Give a very brief answer. 0.02. What is the ratio of the Amount (in current US$) of 1971 in East Asia (developing only) to that in Middle income?
Provide a short and direct response. 0.02. What is the ratio of the Amount (in current US$) of 1972 in East Asia (developing only) to that in Middle income?
Offer a very short reply. 0.03. What is the ratio of the Amount (in current US$) in 1973 in East Asia (developing only) to that in Middle income?
Keep it short and to the point. 0.1. What is the ratio of the Amount (in current US$) in 1970 in Latin America(developing only) to that in Low & middle income?
Offer a terse response. 1.08. What is the ratio of the Amount (in current US$) of 1971 in Latin America(developing only) to that in Low & middle income?
Your response must be concise. 0.97. What is the ratio of the Amount (in current US$) in 1972 in Latin America(developing only) to that in Low & middle income?
Offer a terse response. 1.35. What is the ratio of the Amount (in current US$) of 1973 in Latin America(developing only) to that in Low & middle income?
Provide a short and direct response. 0.88. What is the ratio of the Amount (in current US$) in 1970 in Latin America(developing only) to that in Low income?
Your answer should be very brief. 293.65. What is the ratio of the Amount (in current US$) in 1971 in Latin America(developing only) to that in Low income?
Ensure brevity in your answer.  80.93. What is the ratio of the Amount (in current US$) in 1972 in Latin America(developing only) to that in Low income?
Make the answer very short. 127.63. What is the ratio of the Amount (in current US$) in 1973 in Latin America(developing only) to that in Low income?
Your answer should be very brief. 59.49. What is the ratio of the Amount (in current US$) in 1970 in Latin America(developing only) to that in Lower middle income?
Your response must be concise. 6.2. What is the ratio of the Amount (in current US$) in 1971 in Latin America(developing only) to that in Lower middle income?
Provide a succinct answer. 5.5. What is the ratio of the Amount (in current US$) of 1972 in Latin America(developing only) to that in Lower middle income?
Offer a very short reply. 5.52. What is the ratio of the Amount (in current US$) in 1973 in Latin America(developing only) to that in Lower middle income?
Your response must be concise. 3.04. What is the ratio of the Amount (in current US$) of 1970 in Latin America(developing only) to that in Middle income?
Your answer should be compact. 1.08. What is the ratio of the Amount (in current US$) of 1971 in Latin America(developing only) to that in Middle income?
Offer a terse response. 0.98. What is the ratio of the Amount (in current US$) of 1972 in Latin America(developing only) to that in Middle income?
Provide a succinct answer. 1.37. What is the ratio of the Amount (in current US$) in 1973 in Latin America(developing only) to that in Middle income?
Provide a short and direct response. 0.89. What is the ratio of the Amount (in current US$) in 1970 in Low & middle income to that in Low income?
Your answer should be very brief. 272.33. What is the ratio of the Amount (in current US$) in 1971 in Low & middle income to that in Low income?
Make the answer very short. 83.45. What is the ratio of the Amount (in current US$) in 1972 in Low & middle income to that in Low income?
Provide a succinct answer. 94.35. What is the ratio of the Amount (in current US$) of 1973 in Low & middle income to that in Low income?
Your response must be concise. 67.76. What is the ratio of the Amount (in current US$) of 1970 in Low & middle income to that in Lower middle income?
Offer a terse response. 5.75. What is the ratio of the Amount (in current US$) in 1971 in Low & middle income to that in Lower middle income?
Your response must be concise. 5.67. What is the ratio of the Amount (in current US$) of 1972 in Low & middle income to that in Lower middle income?
Your answer should be compact. 4.08. What is the ratio of the Amount (in current US$) in 1973 in Low & middle income to that in Lower middle income?
Offer a terse response. 3.46. What is the ratio of the Amount (in current US$) in 1971 in Low & middle income to that in Middle income?
Give a very brief answer. 1.01. What is the ratio of the Amount (in current US$) in 1972 in Low & middle income to that in Middle income?
Offer a terse response. 1.01. What is the ratio of the Amount (in current US$) of 1970 in Low income to that in Lower middle income?
Offer a terse response. 0.02. What is the ratio of the Amount (in current US$) of 1971 in Low income to that in Lower middle income?
Your response must be concise. 0.07. What is the ratio of the Amount (in current US$) in 1972 in Low income to that in Lower middle income?
Provide a short and direct response. 0.04. What is the ratio of the Amount (in current US$) of 1973 in Low income to that in Lower middle income?
Offer a terse response. 0.05. What is the ratio of the Amount (in current US$) of 1970 in Low income to that in Middle income?
Ensure brevity in your answer.  0. What is the ratio of the Amount (in current US$) in 1971 in Low income to that in Middle income?
Offer a very short reply. 0.01. What is the ratio of the Amount (in current US$) in 1972 in Low income to that in Middle income?
Your answer should be very brief. 0.01. What is the ratio of the Amount (in current US$) in 1973 in Low income to that in Middle income?
Your answer should be very brief. 0.01. What is the ratio of the Amount (in current US$) of 1970 in Lower middle income to that in Middle income?
Make the answer very short. 0.17. What is the ratio of the Amount (in current US$) in 1971 in Lower middle income to that in Middle income?
Offer a terse response. 0.18. What is the ratio of the Amount (in current US$) of 1972 in Lower middle income to that in Middle income?
Offer a very short reply. 0.25. What is the ratio of the Amount (in current US$) in 1973 in Lower middle income to that in Middle income?
Provide a succinct answer. 0.29. What is the difference between the highest and the second highest Amount (in current US$) in 1970?
Offer a terse response. 1.38e+07. What is the difference between the highest and the second highest Amount (in current US$) in 1971?
Offer a very short reply. 1.86e+06. What is the difference between the highest and the second highest Amount (in current US$) of 1972?
Your response must be concise. 4.44e+07. What is the difference between the highest and the second highest Amount (in current US$) in 1973?
Offer a very short reply. 3.09e+06. What is the difference between the highest and the lowest Amount (in current US$) of 1970?
Give a very brief answer. 1.89e+08. What is the difference between the highest and the lowest Amount (in current US$) in 1971?
Offer a very short reply. 1.53e+08. What is the difference between the highest and the lowest Amount (in current US$) of 1972?
Make the answer very short. 1.69e+08. What is the difference between the highest and the lowest Amount (in current US$) of 1973?
Offer a very short reply. 2.06e+08. 